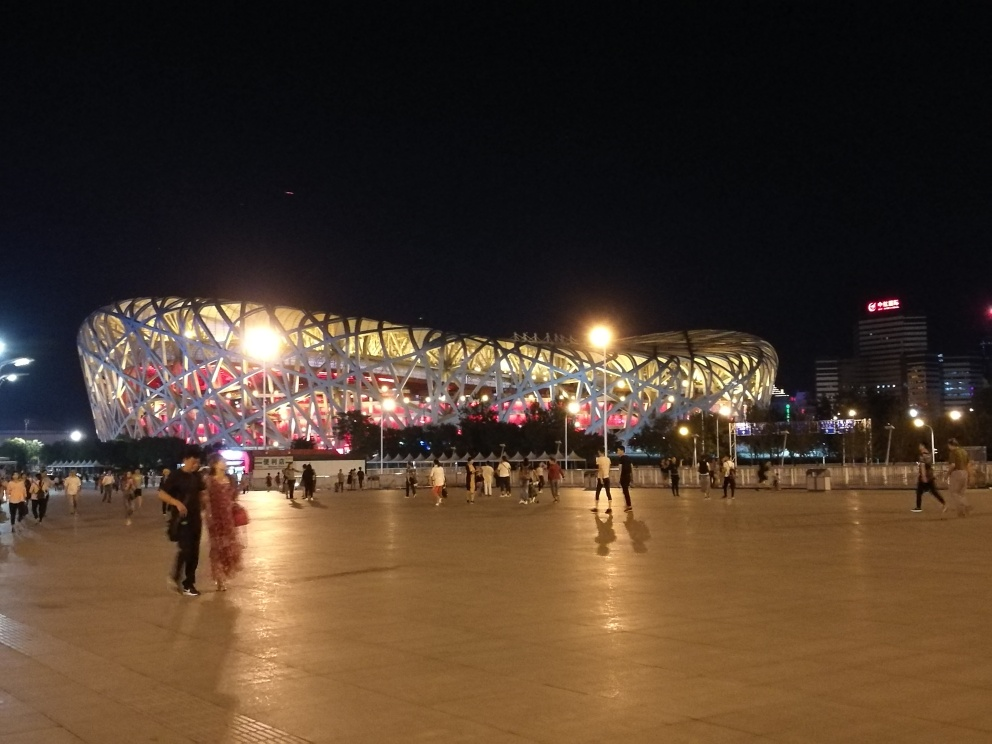Does the image have good contrast? The image presents moderate contrast with the well-lit structure standing out against the night sky; however, the surrounding areas are less distinguishable, which indicates there is room for improvement in contrast for a more balanced image. 